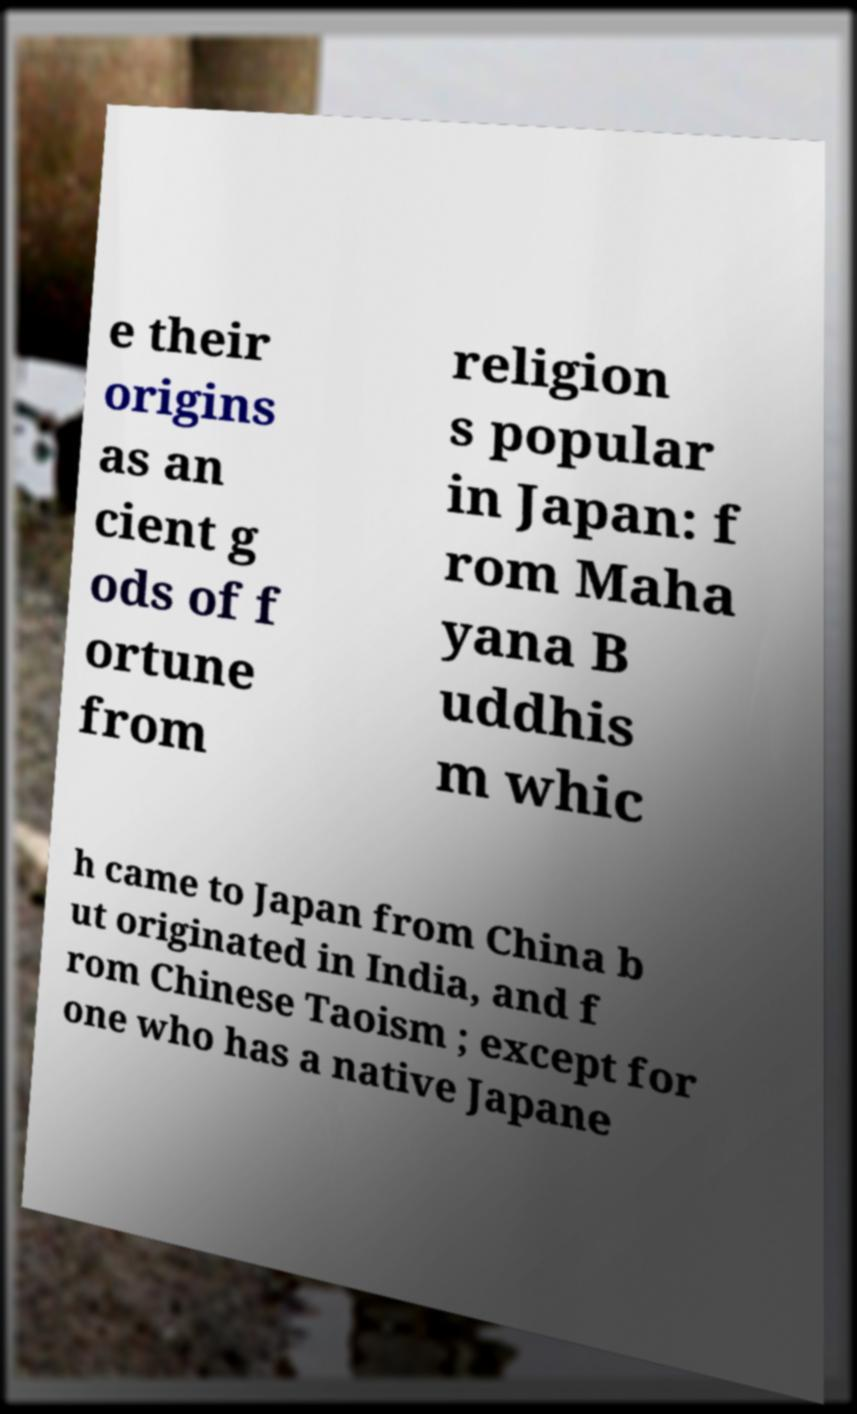For documentation purposes, I need the text within this image transcribed. Could you provide that? e their origins as an cient g ods of f ortune from religion s popular in Japan: f rom Maha yana B uddhis m whic h came to Japan from China b ut originated in India, and f rom Chinese Taoism ; except for one who has a native Japane 